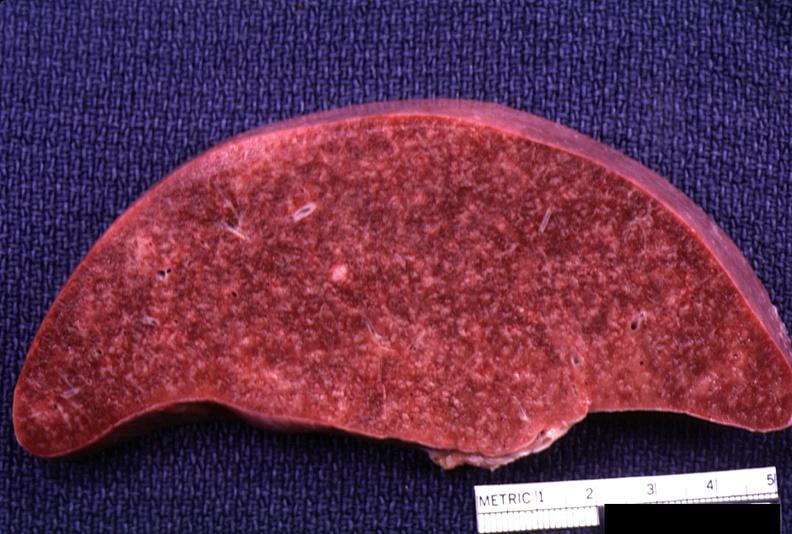does vessel show spleen, lymphoma?
Answer the question using a single word or phrase. No 